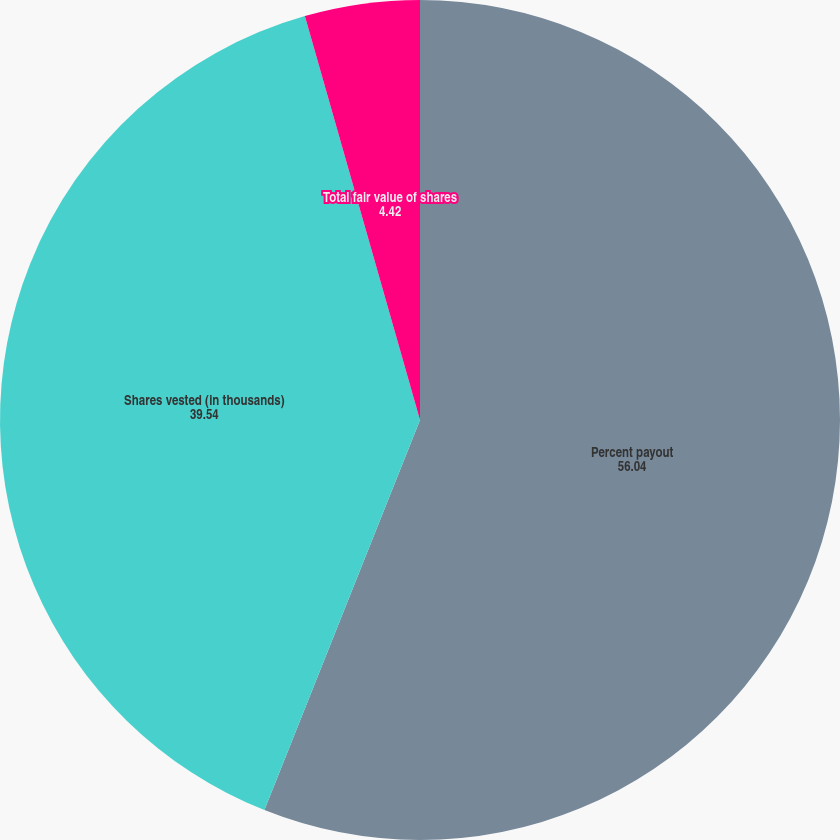<chart> <loc_0><loc_0><loc_500><loc_500><pie_chart><fcel>Percent payout<fcel>Shares vested (in thousands)<fcel>Total fair value of shares<nl><fcel>56.04%<fcel>39.54%<fcel>4.42%<nl></chart> 